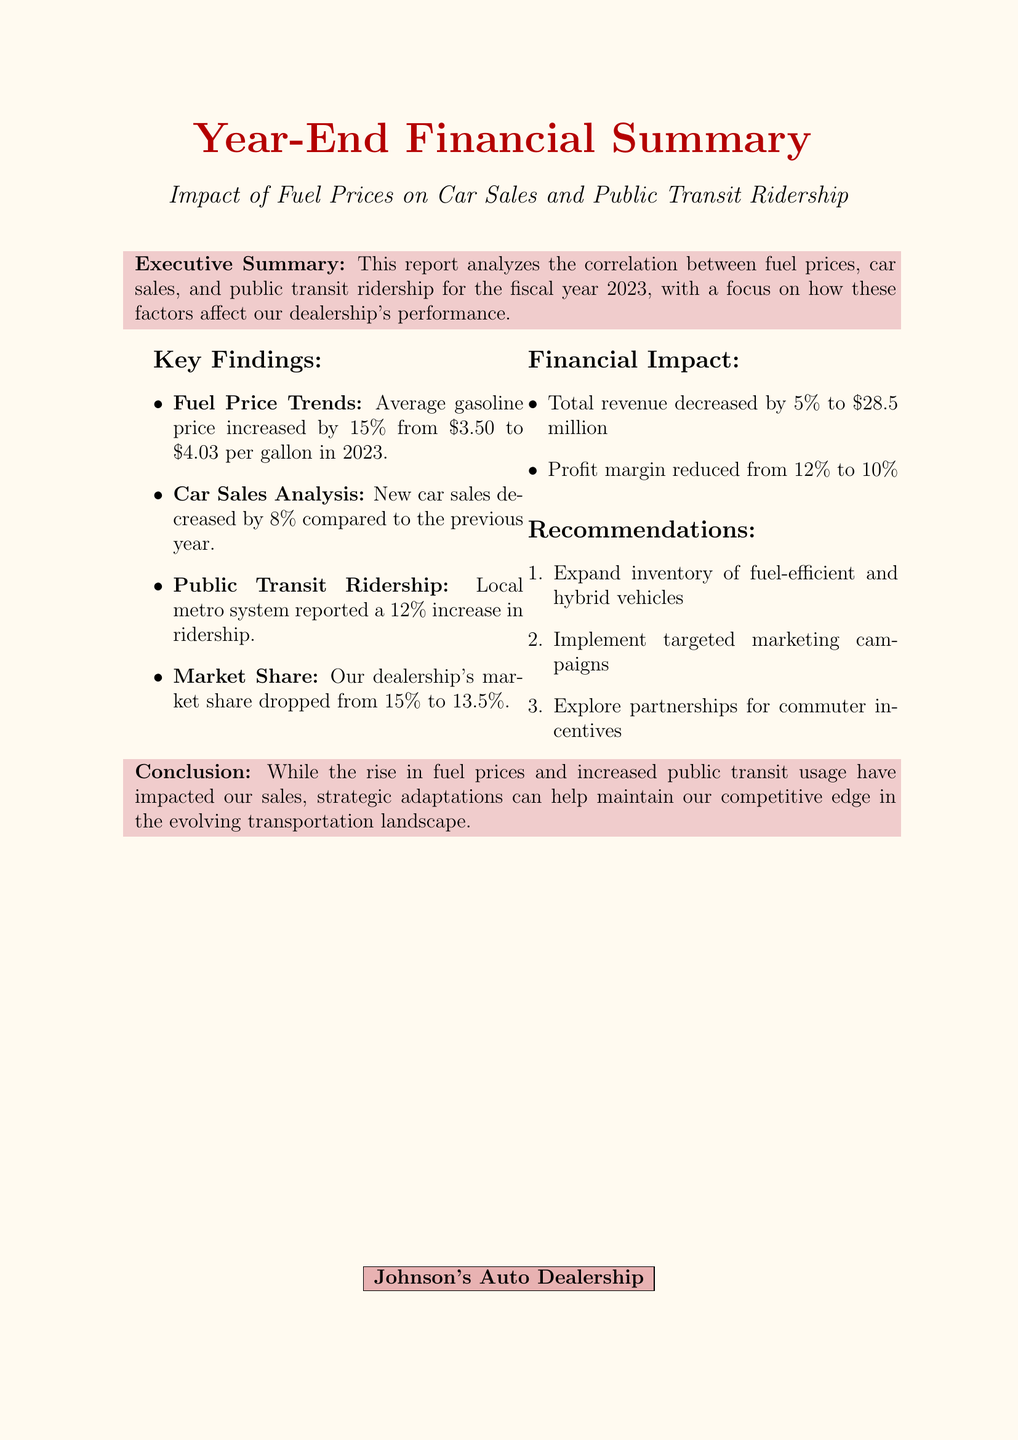What was the average gasoline price in 2023? The document states that the average gasoline price increased by 15% from $3.50 to $4.03 per gallon in 2023.
Answer: $4.03 per gallon By how much did new car sales decrease? The report indicates that new car sales at Johnson's Auto Dealership decreased by 8% compared to the previous year.
Answer: 8% What percentage did public transit ridership increase? The document notes that the local metro system reported a 12% increase in ridership.
Answer: 12% What was the profit margin for the year? The profit margin is mentioned to be reduced from 12% to 10% due to various factors.
Answer: 10% What were the total revenue figures for the dealership? The total revenue is reported as a decrease of 5% to $28.5 million.
Answer: $28.5 million What was the market share of the dealership at the end of the year? The document states the dealership's market share dropped from 15% to 13.5%.
Answer: 13.5% What strategic recommendation is suggested in the report? The recommendations include expanding inventory of fuel-efficient and hybrid vehicles.
Answer: Expand inventory of fuel-efficient and hybrid vehicles What is the conclusion regarding the impact of public transit? The conclusion summarizes that rising fuel prices and increased public transit usage have impacted sales.
Answer: Impacted sales How did increased operational costs affect profit margin? The document explains that the profit margin reduced from 12% to 10% due to increased operational costs.
Answer: Reduced from 12% to 10% 